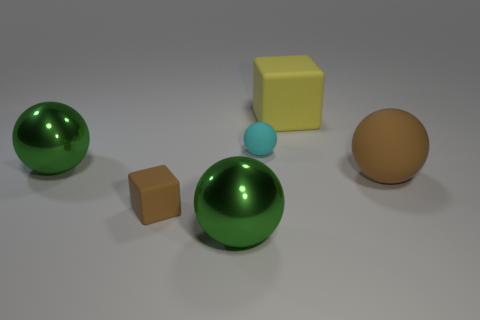What material is the big object behind the large object that is to the left of the brown thing in front of the large brown sphere?
Your answer should be compact. Rubber. What number of small objects are either metal balls or cyan spheres?
Your answer should be compact. 1. How many other objects are the same size as the yellow block?
Keep it short and to the point. 3. There is a large rubber object that is to the left of the brown ball; is it the same shape as the big brown thing?
Offer a very short reply. No. What is the color of the other matte object that is the same shape as the cyan matte thing?
Offer a very short reply. Brown. Are there any other things that have the same shape as the yellow object?
Ensure brevity in your answer.  Yes. Are there an equal number of big yellow rubber objects in front of the yellow matte block and green spheres?
Ensure brevity in your answer.  No. What number of big balls are both to the right of the large yellow rubber object and to the left of the small cyan thing?
Your answer should be compact. 0. The brown rubber thing that is the same shape as the large yellow thing is what size?
Your response must be concise. Small. What number of big objects have the same material as the cyan ball?
Give a very brief answer. 2. 